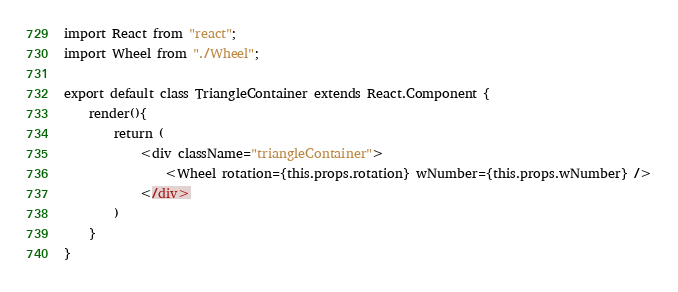Convert code to text. <code><loc_0><loc_0><loc_500><loc_500><_JavaScript_>import React from "react";
import Wheel from "./Wheel";

export default class TriangleContainer extends React.Component {
	render(){
		return (
			<div className="triangleContainer">
				<Wheel rotation={this.props.rotation} wNumber={this.props.wNumber} />
			</div>
		)
	}
}</code> 